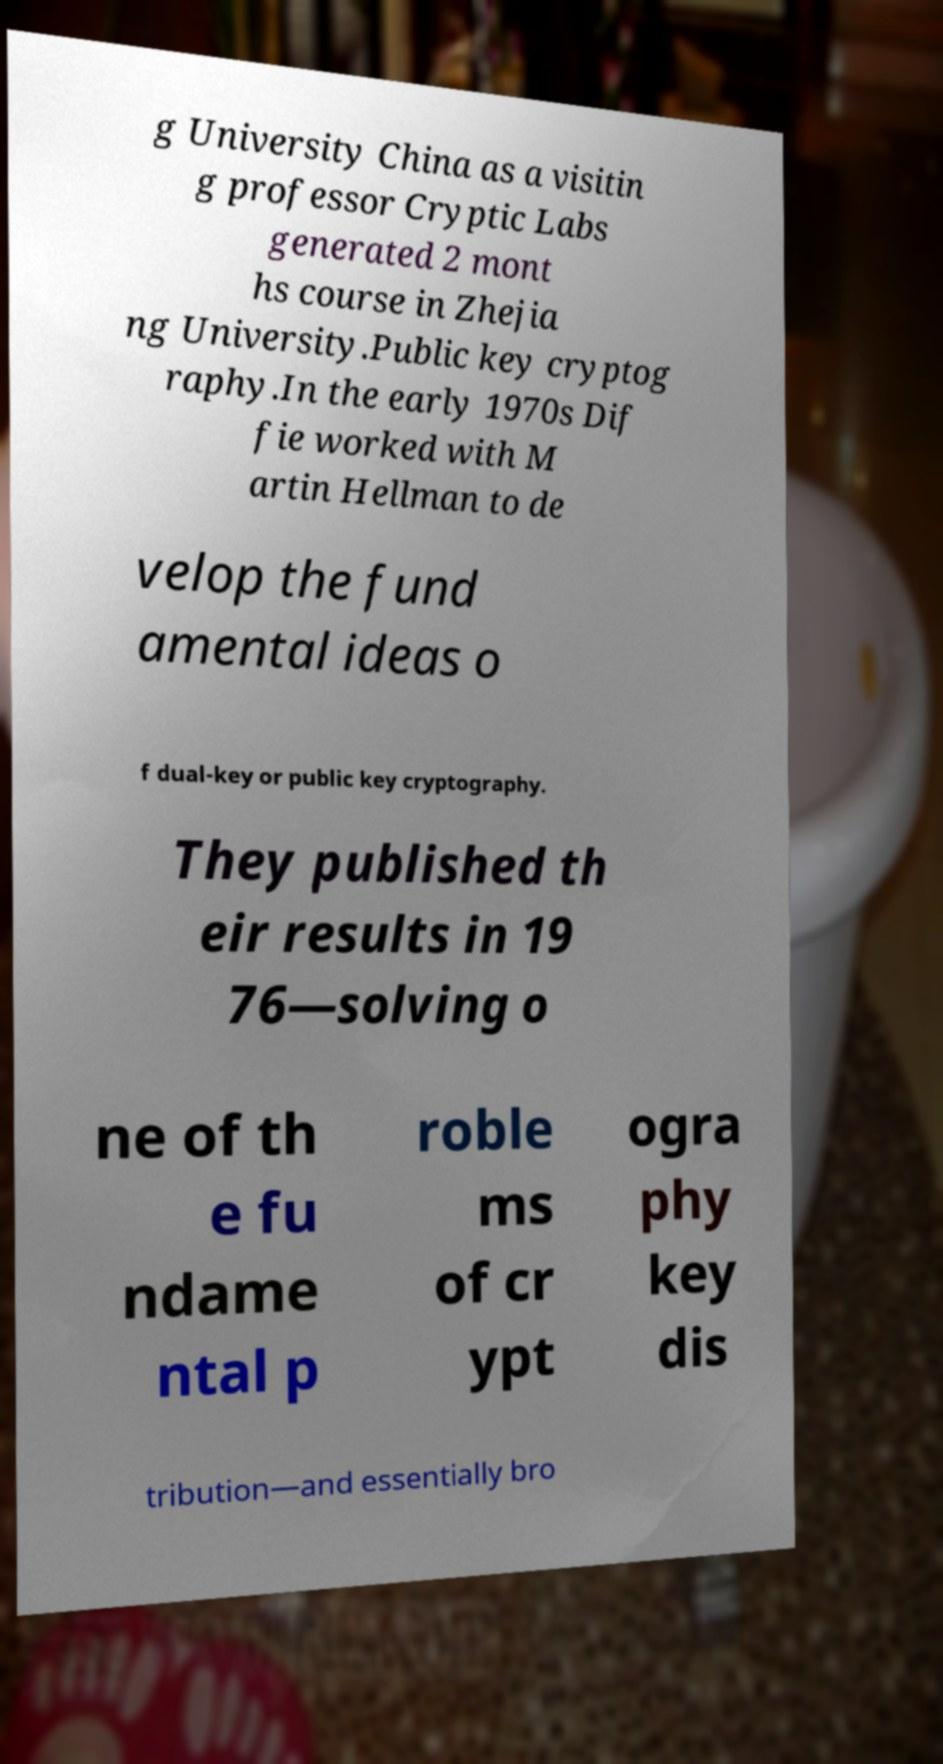Can you accurately transcribe the text from the provided image for me? g University China as a visitin g professor Cryptic Labs generated 2 mont hs course in Zhejia ng University.Public key cryptog raphy.In the early 1970s Dif fie worked with M artin Hellman to de velop the fund amental ideas o f dual-key or public key cryptography. They published th eir results in 19 76—solving o ne of th e fu ndame ntal p roble ms of cr ypt ogra phy key dis tribution—and essentially bro 